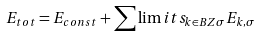<formula> <loc_0><loc_0><loc_500><loc_500>E _ { t o t } = E _ { c o n s t } + \sum \lim i t s _ { k \in B Z \sigma } E _ { k , \sigma }</formula> 